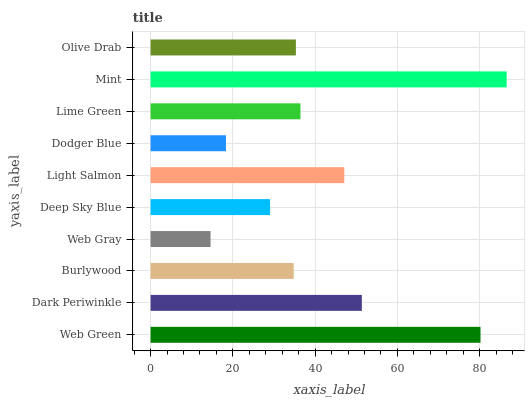Is Web Gray the minimum?
Answer yes or no. Yes. Is Mint the maximum?
Answer yes or no. Yes. Is Dark Periwinkle the minimum?
Answer yes or no. No. Is Dark Periwinkle the maximum?
Answer yes or no. No. Is Web Green greater than Dark Periwinkle?
Answer yes or no. Yes. Is Dark Periwinkle less than Web Green?
Answer yes or no. Yes. Is Dark Periwinkle greater than Web Green?
Answer yes or no. No. Is Web Green less than Dark Periwinkle?
Answer yes or no. No. Is Lime Green the high median?
Answer yes or no. Yes. Is Olive Drab the low median?
Answer yes or no. Yes. Is Web Green the high median?
Answer yes or no. No. Is Mint the low median?
Answer yes or no. No. 